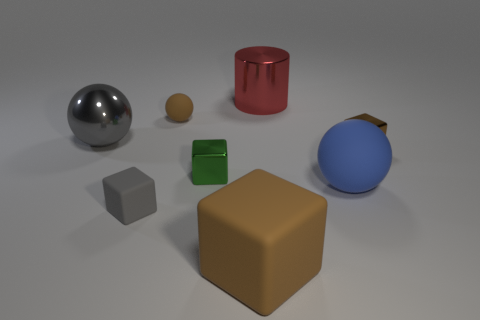Subtract all large matte blocks. How many blocks are left? 3 Add 1 large gray metallic balls. How many objects exist? 9 Subtract all green blocks. How many blocks are left? 3 Subtract all purple balls. How many brown cubes are left? 2 Subtract all spheres. How many objects are left? 5 Subtract 3 blocks. How many blocks are left? 1 Subtract all small brown objects. Subtract all gray spheres. How many objects are left? 5 Add 4 matte blocks. How many matte blocks are left? 6 Add 8 big metallic cylinders. How many big metallic cylinders exist? 9 Subtract 1 gray spheres. How many objects are left? 7 